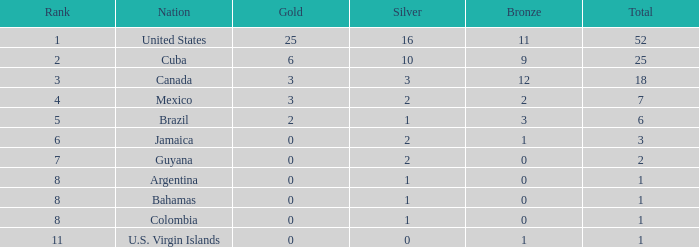What is the fewest number of silver medals a nation who ranked below 8 received? 0.0. 